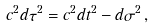<formula> <loc_0><loc_0><loc_500><loc_500>c ^ { 2 } d \tau ^ { 2 } = c ^ { 2 } d t ^ { 2 } - d \sigma ^ { 2 } \, ,</formula> 